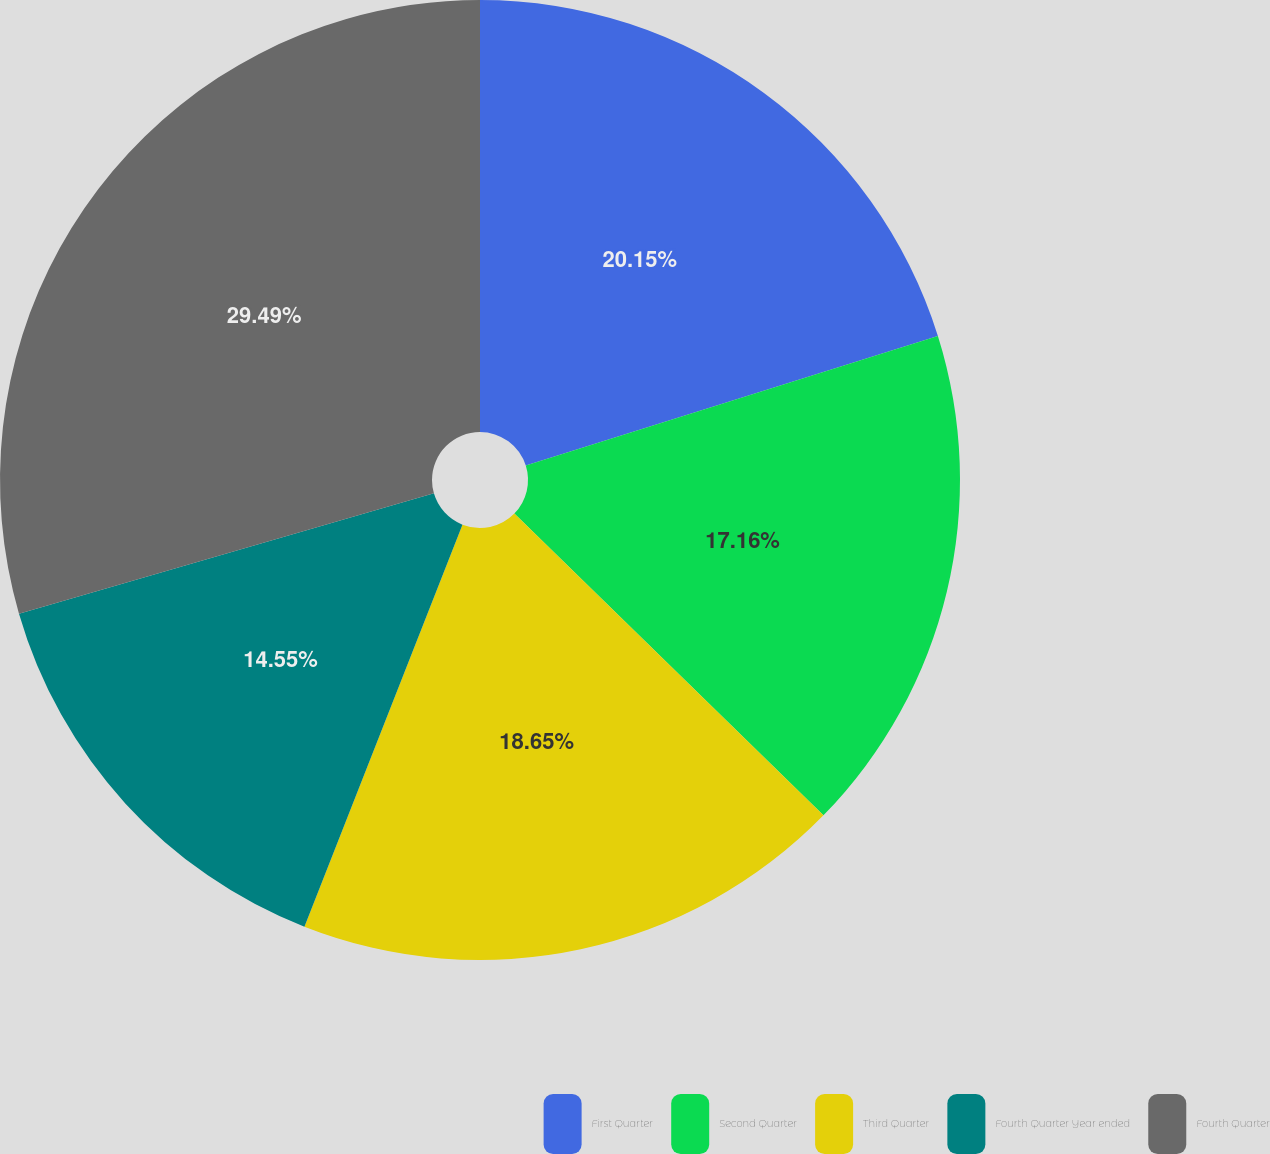Convert chart to OTSL. <chart><loc_0><loc_0><loc_500><loc_500><pie_chart><fcel>First Quarter<fcel>Second Quarter<fcel>Third Quarter<fcel>Fourth Quarter Year ended<fcel>Fourth Quarter<nl><fcel>20.15%<fcel>17.16%<fcel>18.65%<fcel>14.55%<fcel>29.49%<nl></chart> 